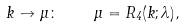Convert formula to latex. <formula><loc_0><loc_0><loc_500><loc_500>k \to \mu \colon \quad \mu = R _ { 4 } ( k ; \lambda ) ,</formula> 